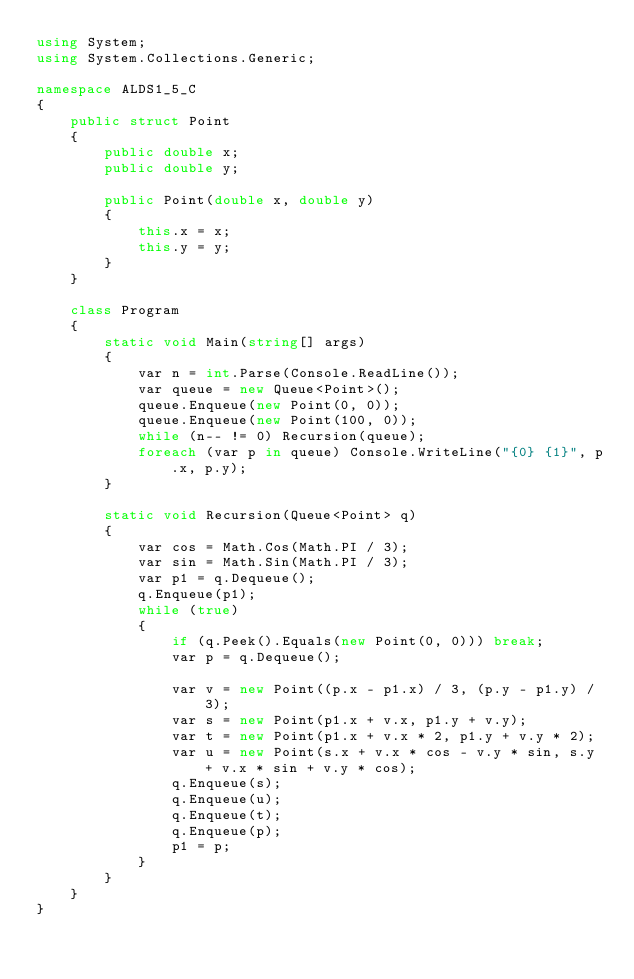<code> <loc_0><loc_0><loc_500><loc_500><_C#_>using System;
using System.Collections.Generic;

namespace ALDS1_5_C
{
    public struct Point
    {
        public double x;
        public double y;

        public Point(double x, double y)
        {
            this.x = x;
            this.y = y;
        }
    }

    class Program
    {
        static void Main(string[] args)
        {
            var n = int.Parse(Console.ReadLine());
            var queue = new Queue<Point>();
            queue.Enqueue(new Point(0, 0));
            queue.Enqueue(new Point(100, 0));
            while (n-- != 0) Recursion(queue);
            foreach (var p in queue) Console.WriteLine("{0} {1}", p.x, p.y);
        }

        static void Recursion(Queue<Point> q)
        {
            var cos = Math.Cos(Math.PI / 3);
            var sin = Math.Sin(Math.PI / 3);
            var p1 = q.Dequeue();
            q.Enqueue(p1);
            while (true)
            {
                if (q.Peek().Equals(new Point(0, 0))) break;
                var p = q.Dequeue();

                var v = new Point((p.x - p1.x) / 3, (p.y - p1.y) / 3);
                var s = new Point(p1.x + v.x, p1.y + v.y);
                var t = new Point(p1.x + v.x * 2, p1.y + v.y * 2);
                var u = new Point(s.x + v.x * cos - v.y * sin, s.y + v.x * sin + v.y * cos);
                q.Enqueue(s);
                q.Enqueue(u);
                q.Enqueue(t);
                q.Enqueue(p);
                p1 = p;
            }
        }
    }
}</code> 